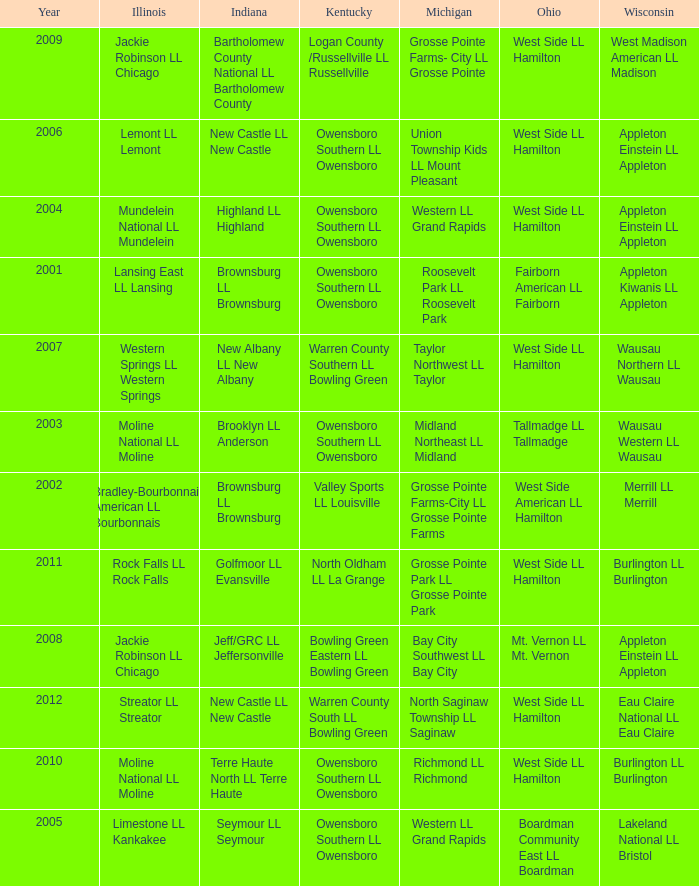What was the little league team from Kentucky when the little league team from Michigan was Grosse Pointe Farms-City LL Grosse Pointe Farms?  Valley Sports LL Louisville. Can you parse all the data within this table? {'header': ['Year', 'Illinois', 'Indiana', 'Kentucky', 'Michigan', 'Ohio', 'Wisconsin'], 'rows': [['2009', 'Jackie Robinson LL Chicago', 'Bartholomew County National LL Bartholomew County', 'Logan County /Russellville LL Russellville', 'Grosse Pointe Farms- City LL Grosse Pointe', 'West Side LL Hamilton', 'West Madison American LL Madison'], ['2006', 'Lemont LL Lemont', 'New Castle LL New Castle', 'Owensboro Southern LL Owensboro', 'Union Township Kids LL Mount Pleasant', 'West Side LL Hamilton', 'Appleton Einstein LL Appleton'], ['2004', 'Mundelein National LL Mundelein', 'Highland LL Highland', 'Owensboro Southern LL Owensboro', 'Western LL Grand Rapids', 'West Side LL Hamilton', 'Appleton Einstein LL Appleton'], ['2001', 'Lansing East LL Lansing', 'Brownsburg LL Brownsburg', 'Owensboro Southern LL Owensboro', 'Roosevelt Park LL Roosevelt Park', 'Fairborn American LL Fairborn', 'Appleton Kiwanis LL Appleton'], ['2007', 'Western Springs LL Western Springs', 'New Albany LL New Albany', 'Warren County Southern LL Bowling Green', 'Taylor Northwest LL Taylor', 'West Side LL Hamilton', 'Wausau Northern LL Wausau'], ['2003', 'Moline National LL Moline', 'Brooklyn LL Anderson', 'Owensboro Southern LL Owensboro', 'Midland Northeast LL Midland', 'Tallmadge LL Tallmadge', 'Wausau Western LL Wausau'], ['2002', 'Bradley-Bourbonnais American LL Bourbonnais', 'Brownsburg LL Brownsburg', 'Valley Sports LL Louisville', 'Grosse Pointe Farms-City LL Grosse Pointe Farms', 'West Side American LL Hamilton', 'Merrill LL Merrill'], ['2011', 'Rock Falls LL Rock Falls', 'Golfmoor LL Evansville', 'North Oldham LL La Grange', 'Grosse Pointe Park LL Grosse Pointe Park', 'West Side LL Hamilton', 'Burlington LL Burlington'], ['2008', 'Jackie Robinson LL Chicago', 'Jeff/GRC LL Jeffersonville', 'Bowling Green Eastern LL Bowling Green', 'Bay City Southwest LL Bay City', 'Mt. Vernon LL Mt. Vernon', 'Appleton Einstein LL Appleton'], ['2012', 'Streator LL Streator', 'New Castle LL New Castle', 'Warren County South LL Bowling Green', 'North Saginaw Township LL Saginaw', 'West Side LL Hamilton', 'Eau Claire National LL Eau Claire'], ['2010', 'Moline National LL Moline', 'Terre Haute North LL Terre Haute', 'Owensboro Southern LL Owensboro', 'Richmond LL Richmond', 'West Side LL Hamilton', 'Burlington LL Burlington'], ['2005', 'Limestone LL Kankakee', 'Seymour LL Seymour', 'Owensboro Southern LL Owensboro', 'Western LL Grand Rapids', 'Boardman Community East LL Boardman', 'Lakeland National LL Bristol']]} 